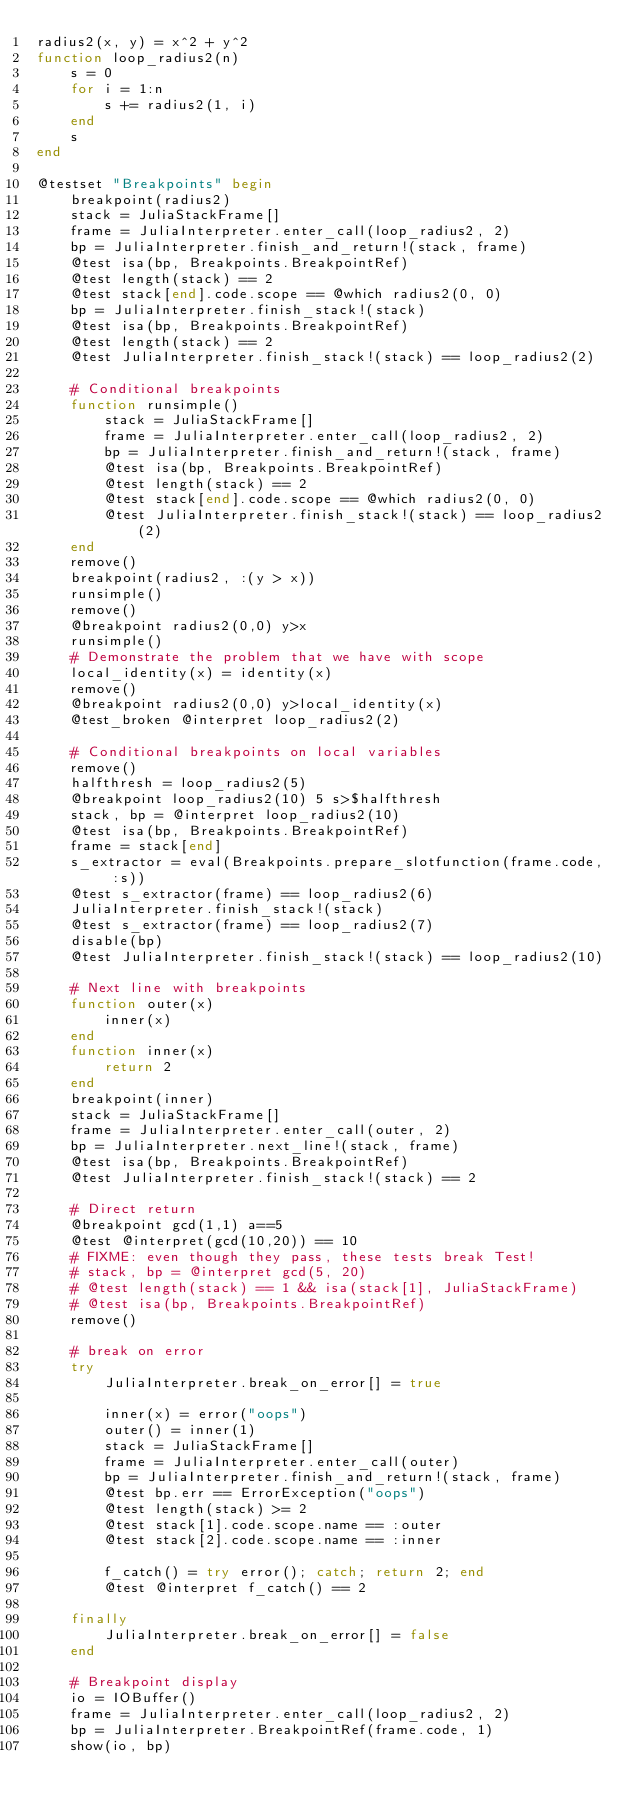<code> <loc_0><loc_0><loc_500><loc_500><_Julia_>radius2(x, y) = x^2 + y^2
function loop_radius2(n)
    s = 0
    for i = 1:n
        s += radius2(1, i)
    end
    s
end

@testset "Breakpoints" begin
    breakpoint(radius2)
    stack = JuliaStackFrame[]
    frame = JuliaInterpreter.enter_call(loop_radius2, 2)
    bp = JuliaInterpreter.finish_and_return!(stack, frame)
    @test isa(bp, Breakpoints.BreakpointRef)
    @test length(stack) == 2
    @test stack[end].code.scope == @which radius2(0, 0)
    bp = JuliaInterpreter.finish_stack!(stack)
    @test isa(bp, Breakpoints.BreakpointRef)
    @test length(stack) == 2
    @test JuliaInterpreter.finish_stack!(stack) == loop_radius2(2)

    # Conditional breakpoints
    function runsimple()
        stack = JuliaStackFrame[]
        frame = JuliaInterpreter.enter_call(loop_radius2, 2)
        bp = JuliaInterpreter.finish_and_return!(stack, frame)
        @test isa(bp, Breakpoints.BreakpointRef)
        @test length(stack) == 2
        @test stack[end].code.scope == @which radius2(0, 0)
        @test JuliaInterpreter.finish_stack!(stack) == loop_radius2(2)
    end
    remove()
    breakpoint(radius2, :(y > x))
    runsimple()
    remove()
    @breakpoint radius2(0,0) y>x
    runsimple()
    # Demonstrate the problem that we have with scope
    local_identity(x) = identity(x)
    remove()
    @breakpoint radius2(0,0) y>local_identity(x)
    @test_broken @interpret loop_radius2(2)

    # Conditional breakpoints on local variables
    remove()
    halfthresh = loop_radius2(5)
    @breakpoint loop_radius2(10) 5 s>$halfthresh
    stack, bp = @interpret loop_radius2(10)
    @test isa(bp, Breakpoints.BreakpointRef)
    frame = stack[end]
    s_extractor = eval(Breakpoints.prepare_slotfunction(frame.code, :s))
    @test s_extractor(frame) == loop_radius2(6)
    JuliaInterpreter.finish_stack!(stack)
    @test s_extractor(frame) == loop_radius2(7)
    disable(bp)
    @test JuliaInterpreter.finish_stack!(stack) == loop_radius2(10)

    # Next line with breakpoints
    function outer(x)
        inner(x)
    end
    function inner(x)
        return 2
    end
    breakpoint(inner)
    stack = JuliaStackFrame[]
    frame = JuliaInterpreter.enter_call(outer, 2)
    bp = JuliaInterpreter.next_line!(stack, frame)
    @test isa(bp, Breakpoints.BreakpointRef)
    @test JuliaInterpreter.finish_stack!(stack) == 2

    # Direct return
    @breakpoint gcd(1,1) a==5
    @test @interpret(gcd(10,20)) == 10
    # FIXME: even though they pass, these tests break Test!
    # stack, bp = @interpret gcd(5, 20)
    # @test length(stack) == 1 && isa(stack[1], JuliaStackFrame)
    # @test isa(bp, Breakpoints.BreakpointRef)
    remove()

    # break on error
    try
        JuliaInterpreter.break_on_error[] = true

        inner(x) = error("oops")
        outer() = inner(1)
        stack = JuliaStackFrame[]
        frame = JuliaInterpreter.enter_call(outer)
        bp = JuliaInterpreter.finish_and_return!(stack, frame)
        @test bp.err == ErrorException("oops")
        @test length(stack) >= 2
        @test stack[1].code.scope.name == :outer
        @test stack[2].code.scope.name == :inner

        f_catch() = try error(); catch; return 2; end
        @test @interpret f_catch() == 2

    finally
        JuliaInterpreter.break_on_error[] = false
    end

    # Breakpoint display
    io = IOBuffer()
    frame = JuliaInterpreter.enter_call(loop_radius2, 2)
    bp = JuliaInterpreter.BreakpointRef(frame.code, 1)
    show(io, bp)</code> 